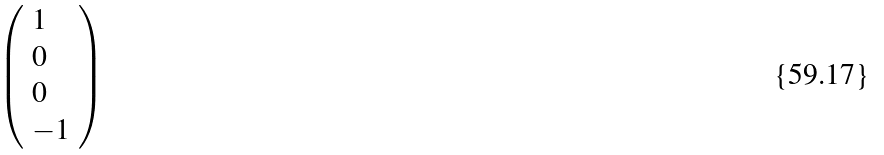<formula> <loc_0><loc_0><loc_500><loc_500>\left ( \begin{array} { l } { 1 } \\ { 0 } \\ { 0 } \\ { - 1 } \end{array} \right )</formula> 